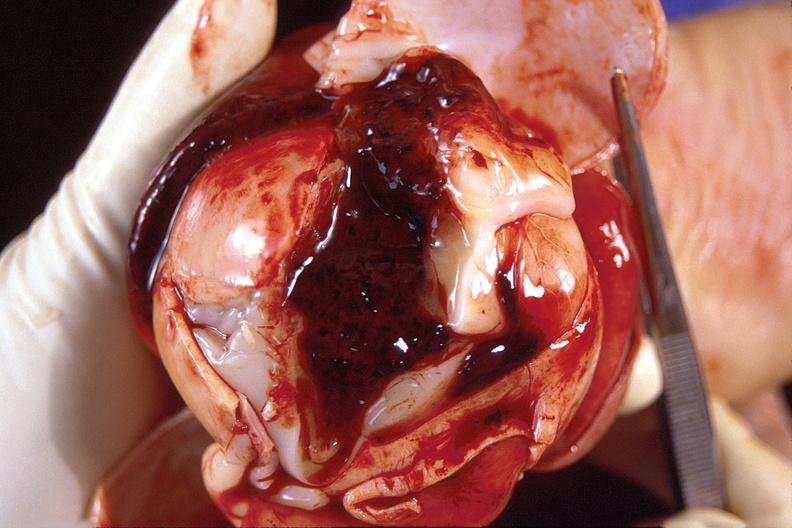what does this image show?
Answer the question using a single word or phrase. Brain 